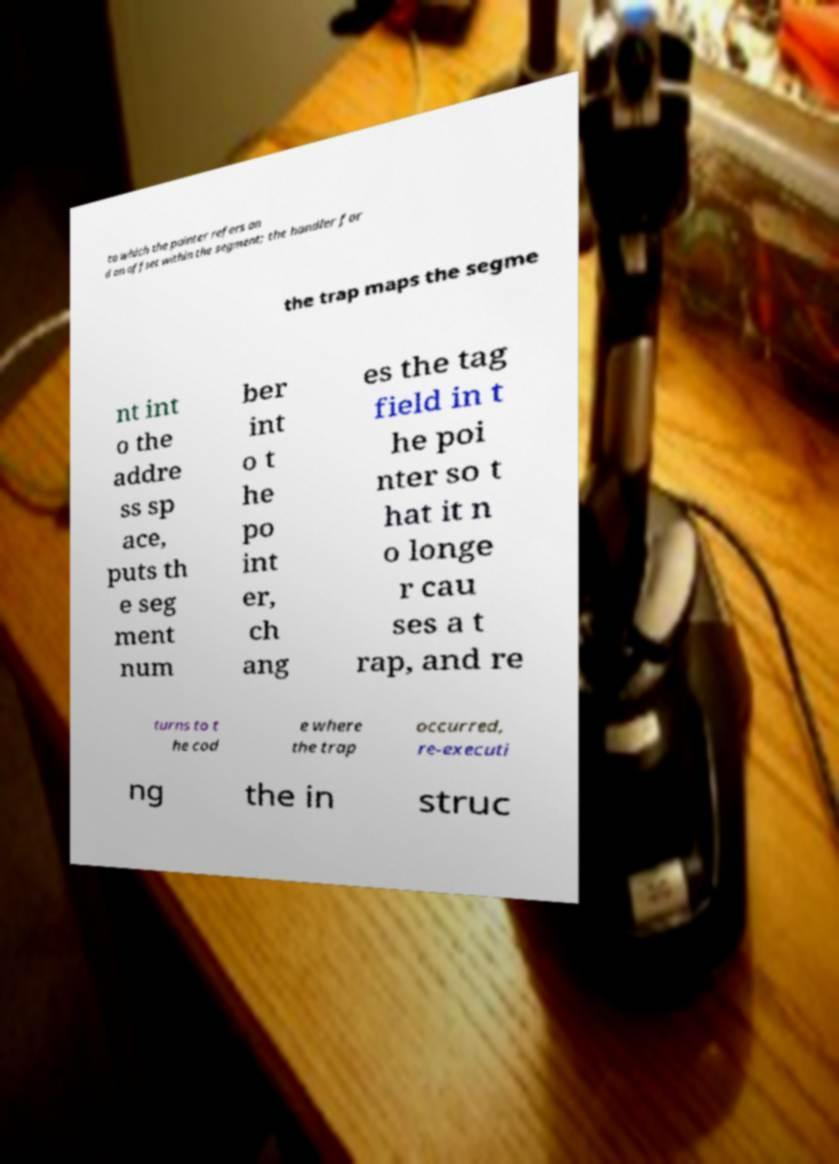I need the written content from this picture converted into text. Can you do that? to which the pointer refers an d an offset within the segment; the handler for the trap maps the segme nt int o the addre ss sp ace, puts th e seg ment num ber int o t he po int er, ch ang es the tag field in t he poi nter so t hat it n o longe r cau ses a t rap, and re turns to t he cod e where the trap occurred, re-executi ng the in struc 